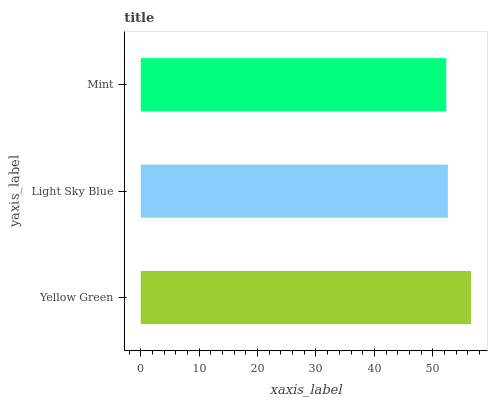Is Mint the minimum?
Answer yes or no. Yes. Is Yellow Green the maximum?
Answer yes or no. Yes. Is Light Sky Blue the minimum?
Answer yes or no. No. Is Light Sky Blue the maximum?
Answer yes or no. No. Is Yellow Green greater than Light Sky Blue?
Answer yes or no. Yes. Is Light Sky Blue less than Yellow Green?
Answer yes or no. Yes. Is Light Sky Blue greater than Yellow Green?
Answer yes or no. No. Is Yellow Green less than Light Sky Blue?
Answer yes or no. No. Is Light Sky Blue the high median?
Answer yes or no. Yes. Is Light Sky Blue the low median?
Answer yes or no. Yes. Is Mint the high median?
Answer yes or no. No. Is Mint the low median?
Answer yes or no. No. 